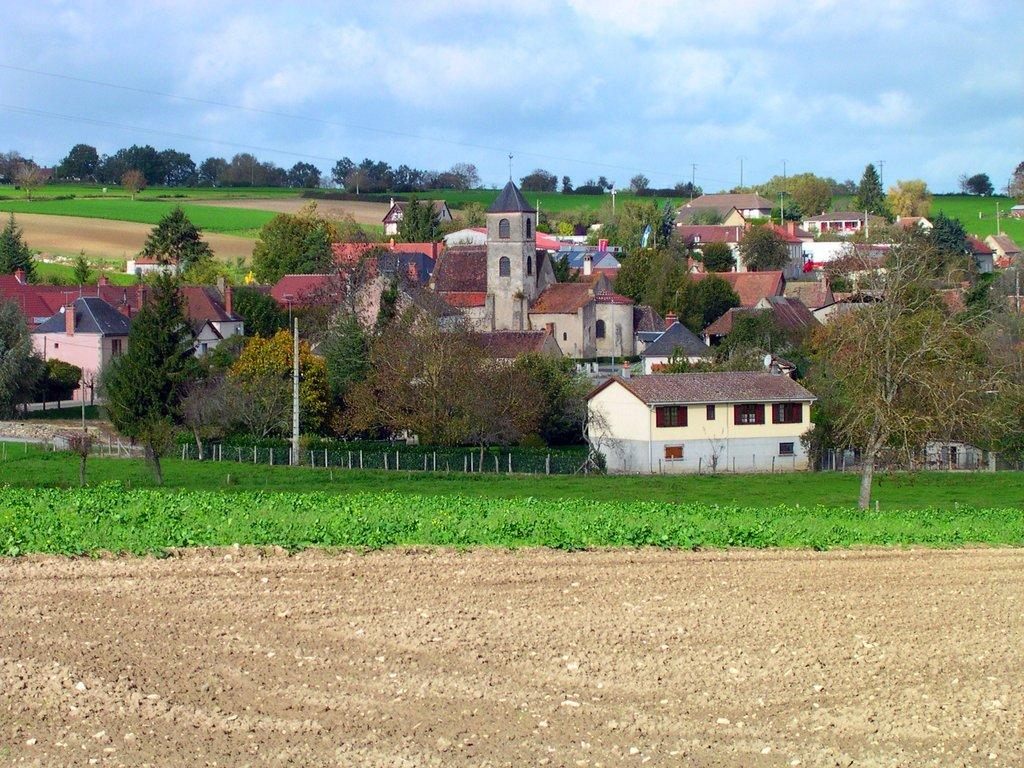What type of structures are present in the image? There are buildings in the image. What colors are the buildings? The buildings are in white and gray colors. What other natural elements can be seen in the image? There are trees in the image. What color are the trees? The trees are in green color. What is visible in the background of the image? The background sky is in white and blue color. Can you tell me how many bags of popcorn are on the roof of the building in the image? There is no popcorn present in the image; it only features buildings, trees, and a sky background. What type of underground space is visible in the image? There is no underground space or cellar visible in the image; it only features buildings, trees, and a sky background. 